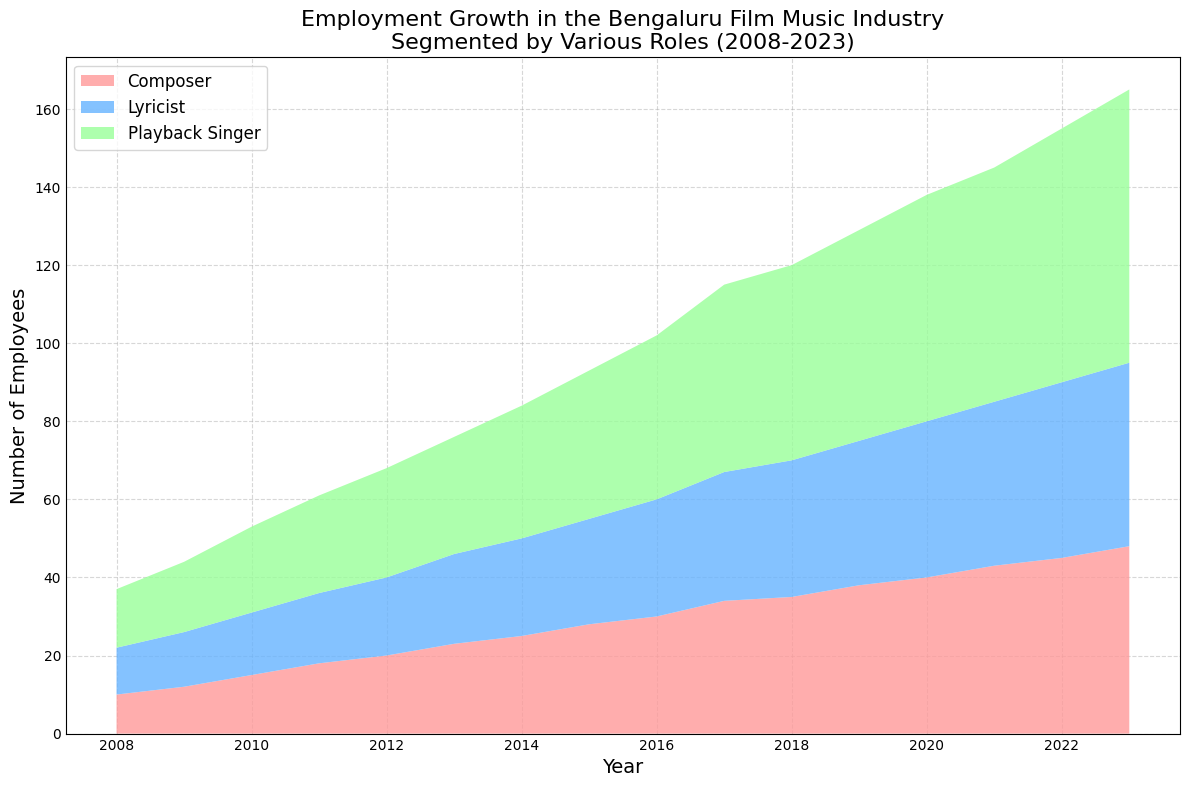What role had the highest employment in 2023? Look at the stackplot for 2023 and observe the segment heights for Composer, Lyricist, and Playback Singer. The tallest segment represents Playback Singer.
Answer: Playback Singer In which year did the gap between the number of Composers and Playback Singers first exceed 20? Calculate the difference in each year by referring to the chart. In 2013, the difference between Composers (23) and Playback Singers (30) exceeded 20 for the first time.
Answer: 2013 By how much did the total number of employees (all roles combined) grow from 2008 to 2023? In 2008, the total is 10 (Composers) + 12 (Lyricists) + 15 (Playback Singers) = 37. In 2023, it is 48 (Composers) + 47 (Lyricists) + 70 (Playback Singers) = 165. The growth is 165 - 37.
Answer: 128 What is the average annual growth rate of Lyricists between 2008 and 2023? Calculate the total growth in Lyricists from 12 in 2008 to 47 in 2023 which is 47 - 12 = 35. Divide by the number of years, 2023 - 2008 = 15. So, 35 / 15.
Answer: 2.33 Between which two consecutive years did the number of Playback Singers grow the most? Observe the increments in each year’s stack plot. The largest increment is between 2019 and 2020 (54 to 58).
Answer: 2019-2020 During which year did the total employment (all roles) first exceed 100? Sum the numbers for each year and identify when the sum exceeds 100. The year when this first happens is 2015.
Answer: 2015 Compare the employment numbers for Composers and Lyricists in 2010. Which role has more employees and by how much? In 2010, there are 15 Composers and 16 Lyricists. Lyricists have more employees by 1.
Answer: Lyricists, 1 Which role experienced the least consistent growth over the years? Examine the trendline for each role and identify the one with the most fluctuations. The Playback Singer role appears to have the most varied increments, indicating less consistency.
Answer: Playback Singer By what proportion did the number of Playback Singers increase from 2008 to 2023? Compute the ratio, where the number in 2023 is 70 and in 2008 is 15. So, 70 / 15.
Answer: 4.67 